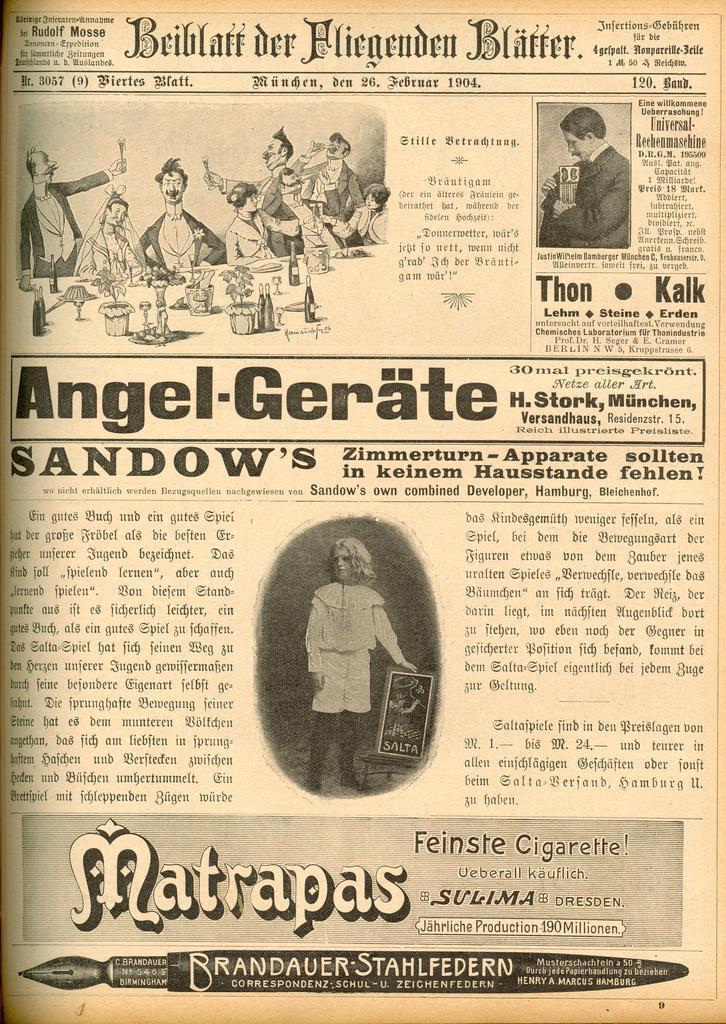How would you summarize this image in a sentence or two? This is a poster and in this poster we can see some people, bottles, some objects and some text. 